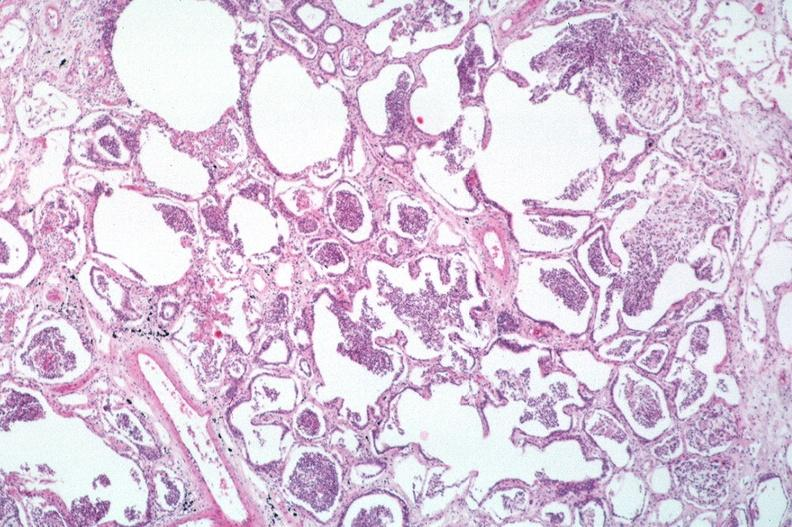what does this image show?
Answer the question using a single word or phrase. Lung 